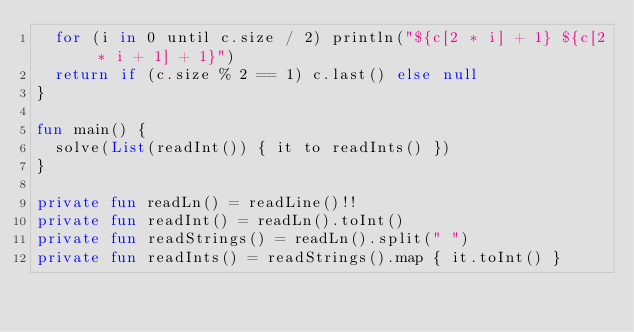<code> <loc_0><loc_0><loc_500><loc_500><_Kotlin_>	for (i in 0 until c.size / 2) println("${c[2 * i] + 1} ${c[2 * i + 1] + 1}")
	return if (c.size % 2 == 1) c.last() else null
}

fun main() {
	solve(List(readInt()) { it to readInts() })
}

private fun readLn() = readLine()!!
private fun readInt() = readLn().toInt()
private fun readStrings() = readLn().split(" ")
private fun readInts() = readStrings().map { it.toInt() }
</code> 